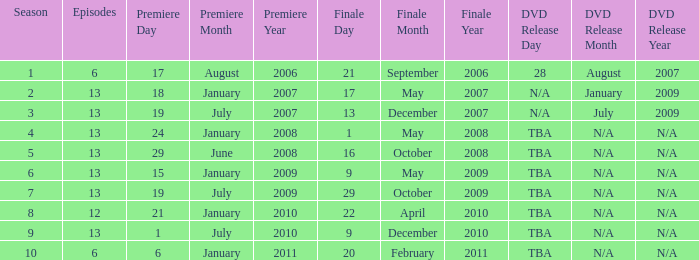On what date was the DVD released for the season with fewer than 13 episodes that aired before season 8? August 28, 2007. 